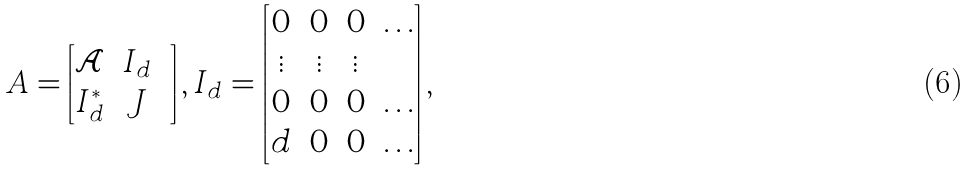<formula> <loc_0><loc_0><loc_500><loc_500>A = \begin{bmatrix} \mathcal { A } & I _ { d } \\ I _ { d } ^ { * } & J & \end{bmatrix} , I _ { d } = \begin{bmatrix} 0 & 0 & 0 & \dots \\ \vdots & \vdots & \vdots & \\ 0 & 0 & 0 & \dots \\ d & 0 & 0 & \dots \end{bmatrix} ,</formula> 